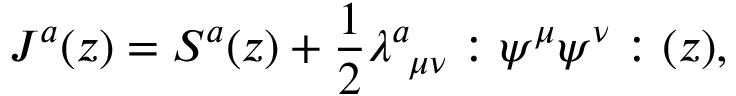Convert formula to latex. <formula><loc_0><loc_0><loc_500><loc_500>J ^ { a } ( z ) = S ^ { a } ( z ) + \frac { 1 } { 2 } \lambda _ { \mu \nu } ^ { a } \colon \psi ^ { \mu } \psi ^ { \nu } \colon ( z ) ,</formula> 